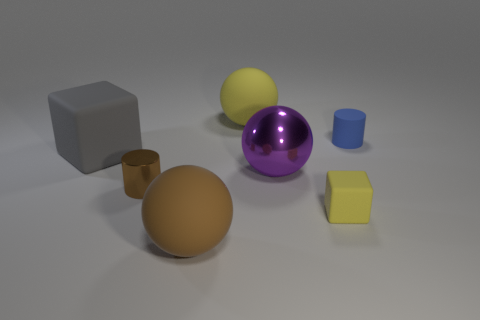Add 2 rubber cylinders. How many objects exist? 9 Subtract all cubes. How many objects are left? 5 Subtract all big matte objects. Subtract all small blue objects. How many objects are left? 3 Add 5 tiny metal cylinders. How many tiny metal cylinders are left? 6 Add 4 small brown matte cubes. How many small brown matte cubes exist? 4 Subtract 1 blue cylinders. How many objects are left? 6 